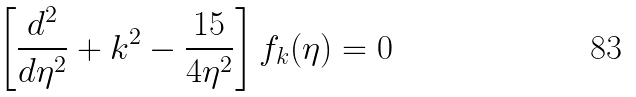<formula> <loc_0><loc_0><loc_500><loc_500>\left [ \frac { d ^ { 2 } } { d \eta ^ { 2 } } + k ^ { 2 } - \frac { 1 5 } { 4 \eta ^ { 2 } } \right ] f _ { k } ( \eta ) = 0</formula> 